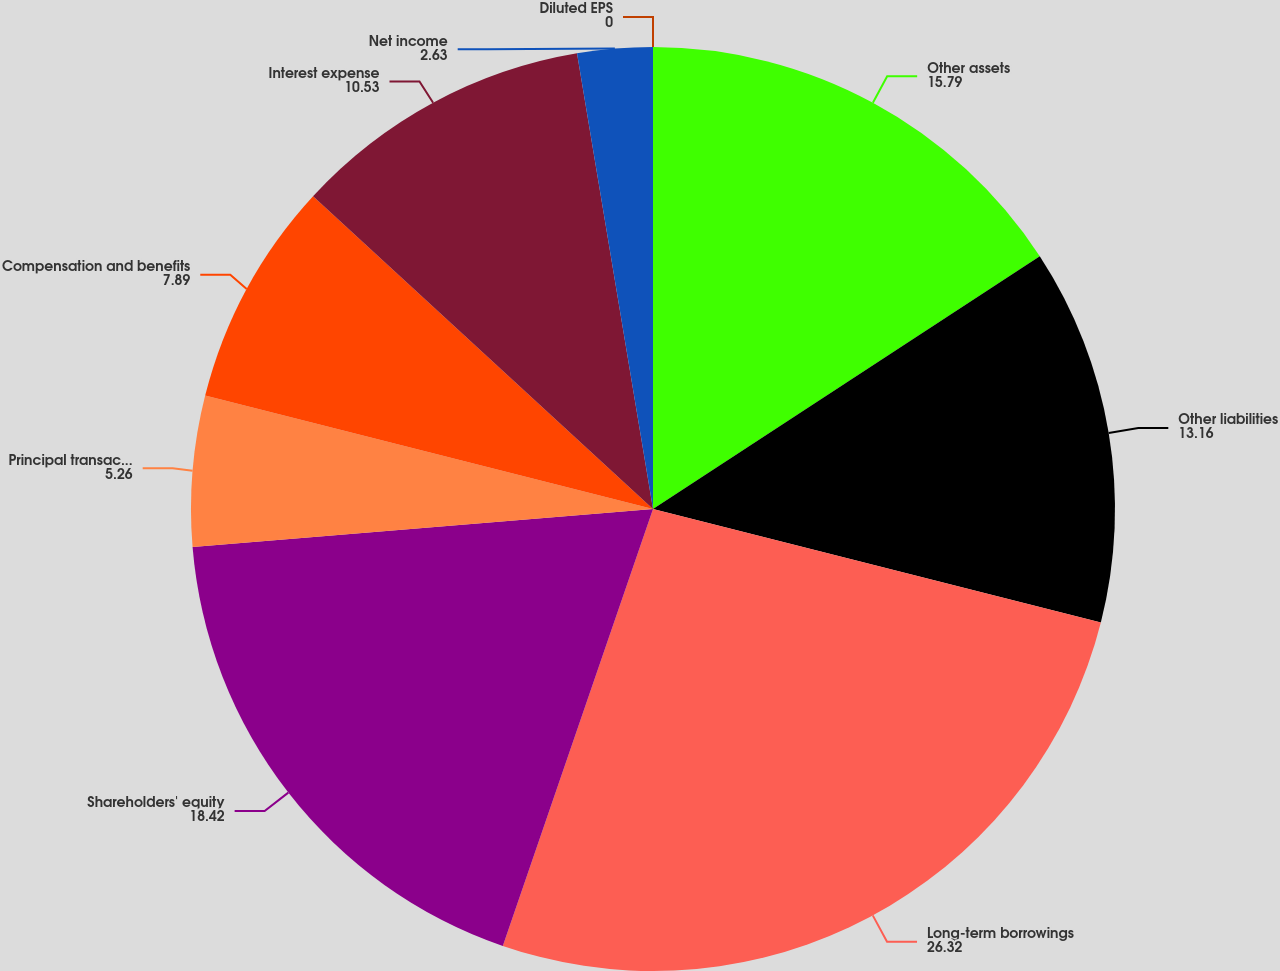Convert chart. <chart><loc_0><loc_0><loc_500><loc_500><pie_chart><fcel>Other assets<fcel>Other liabilities<fcel>Long-term borrowings<fcel>Shareholders' equity<fcel>Principal transactions trading<fcel>Compensation and benefits<fcel>Interest expense<fcel>Net income<fcel>Diluted EPS<nl><fcel>15.79%<fcel>13.16%<fcel>26.32%<fcel>18.42%<fcel>5.26%<fcel>7.89%<fcel>10.53%<fcel>2.63%<fcel>0.0%<nl></chart> 